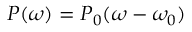<formula> <loc_0><loc_0><loc_500><loc_500>P ( \omega ) = P _ { 0 } ( \omega - \omega _ { 0 } )</formula> 